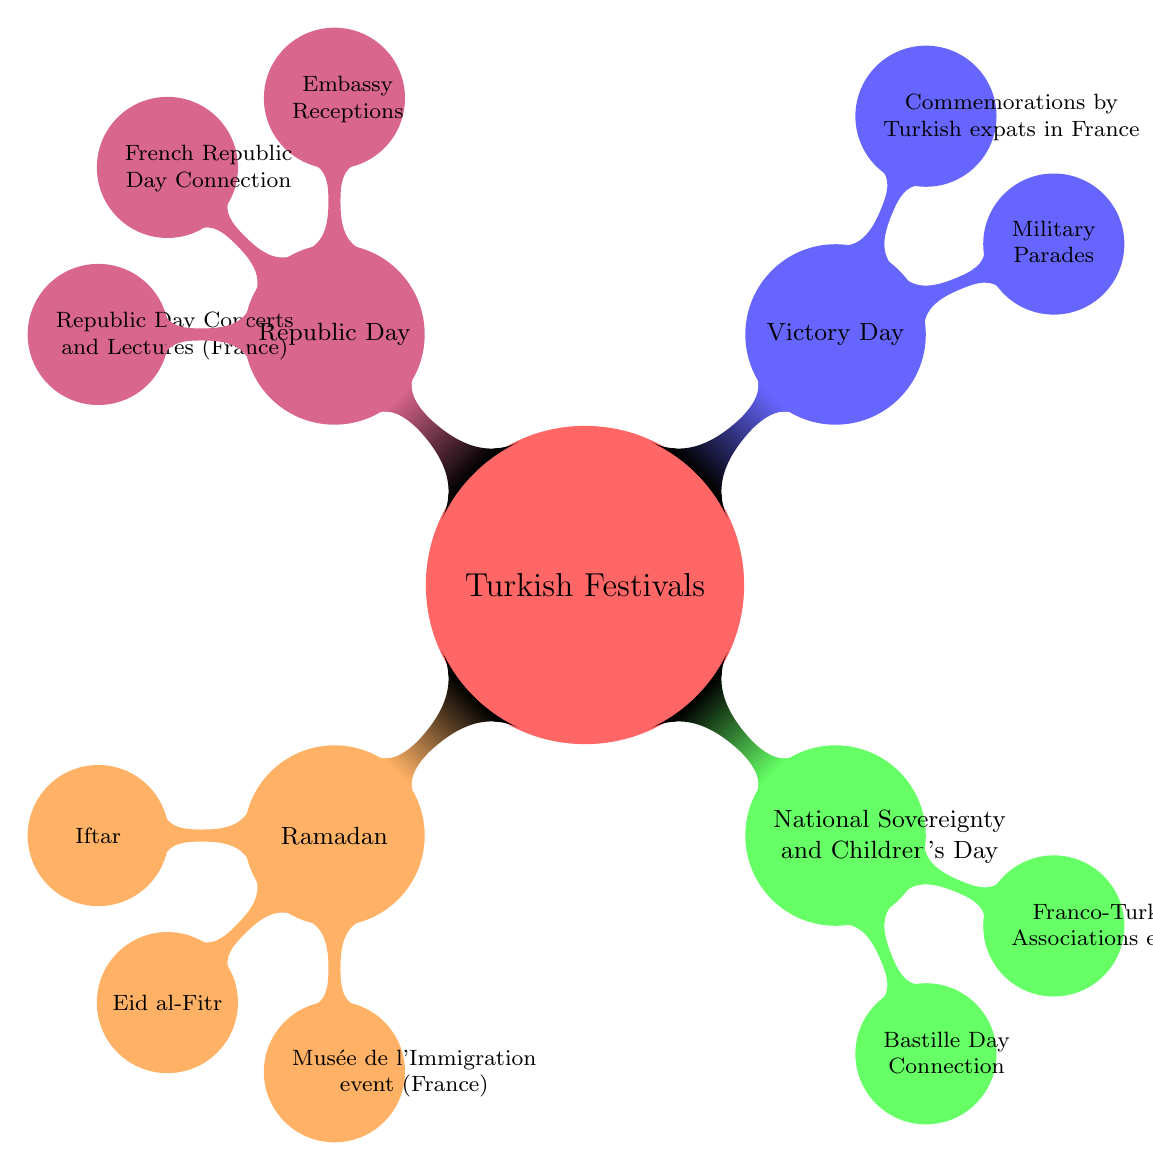What is the first Turkish festival mentioned in the diagram? The diagram lists "Ramadan" as the first child node under the main node "Turkish Festivals," indicating that it is the first festival presented.
Answer: Ramadan How many major Turkish festivals are listed in the diagram? The diagram has four child nodes branching from the "Turkish Festivals" node, representing four different festivals, confirming that there are a total of four major festivals mentioned.
Answer: 4 What event is associated with 'Eid al-Fitr' in France? Under the "Ramadan" festival, the diagram shows a node labeled "Musée de l'Immigration event (France)", indicating it is associated with Eid al-Fitr celebrations in France.
Answer: Musée de l'Immigration event (France) Which festival is connected to France's Bastille Day? The diagram indicates that 'National Sovereignty and Children's Day' has a child node explicitly mentioning its connection to "Bastille Day," showing the association of these two events.
Answer: Bastille Day Connection What type of commemorations occur on Victory Day? Under 'Victory Day', the diagram mentions "Commemorations by Turkish expats in France," indicating that these commemorations are specifically performed by the Turkish expatriate community in France.
Answer: Commemorations by Turkish expats in France How many events are listed under Republic Day? The diagram shows three child nodes branching from 'Republic Day,' listing the related events under this festival, which indicates that there are three specific events associated with it.
Answer: 3 What is shared between Republic Day and French Republic Day? The node labeled "French Republic Day Connection" directly associates Republic Day with a celebration occurring in France, highlighting the relationship between these two national celebrations.
Answer: French Republic Day Connection What type of events are mentioned for National Sovereignty and Children's Day? The diagram specifies 'Franco-Turkish Associations events' under this festival, indicating the involvement of cultural associations in the celebration of National Sovereignty and Children's Day in France.
Answer: Franco-Turkish Associations events 